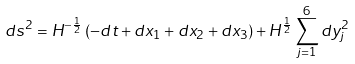<formula> <loc_0><loc_0><loc_500><loc_500>d s ^ { 2 } = H ^ { - \frac { 1 } { 2 } } \left ( - d t + d x _ { 1 } + d x _ { 2 } + d x _ { 3 } \right ) + H ^ { \frac { 1 } { 2 } } \sum _ { j = 1 } ^ { 6 } d y _ { j } ^ { 2 }</formula> 